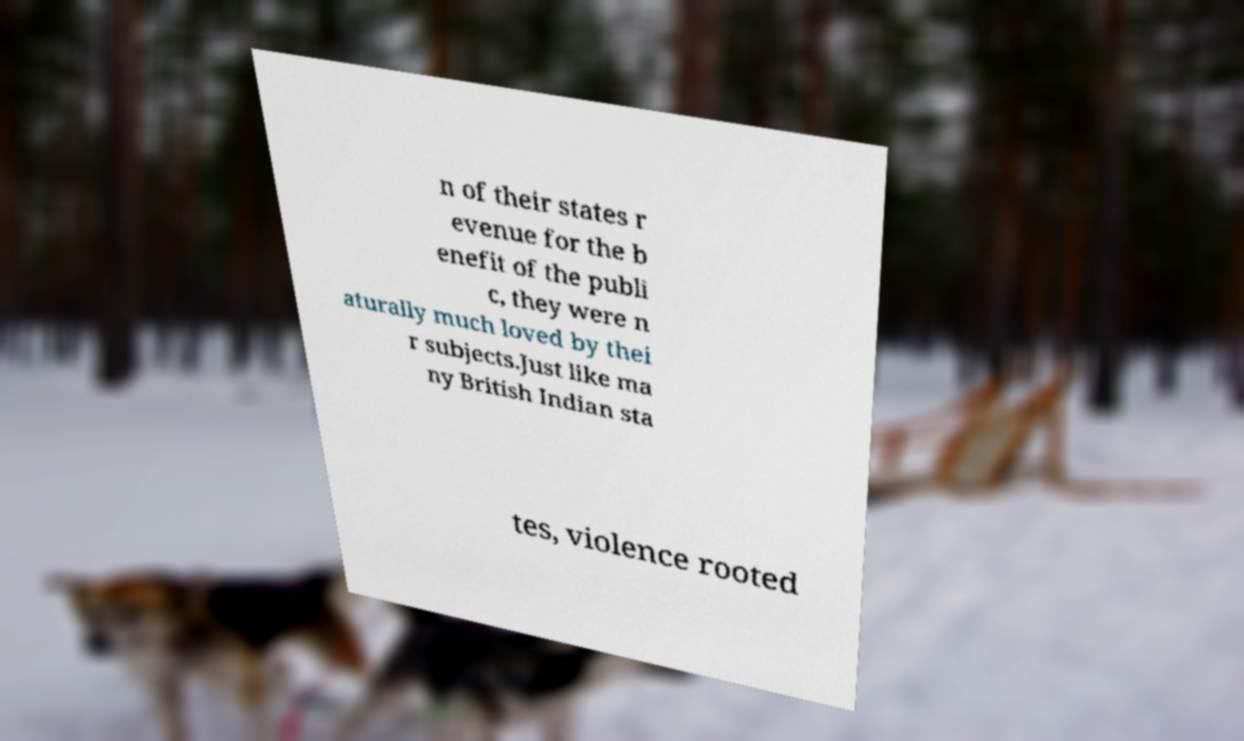Please identify and transcribe the text found in this image. n of their states r evenue for the b enefit of the publi c, they were n aturally much loved by thei r subjects.Just like ma ny British Indian sta tes, violence rooted 